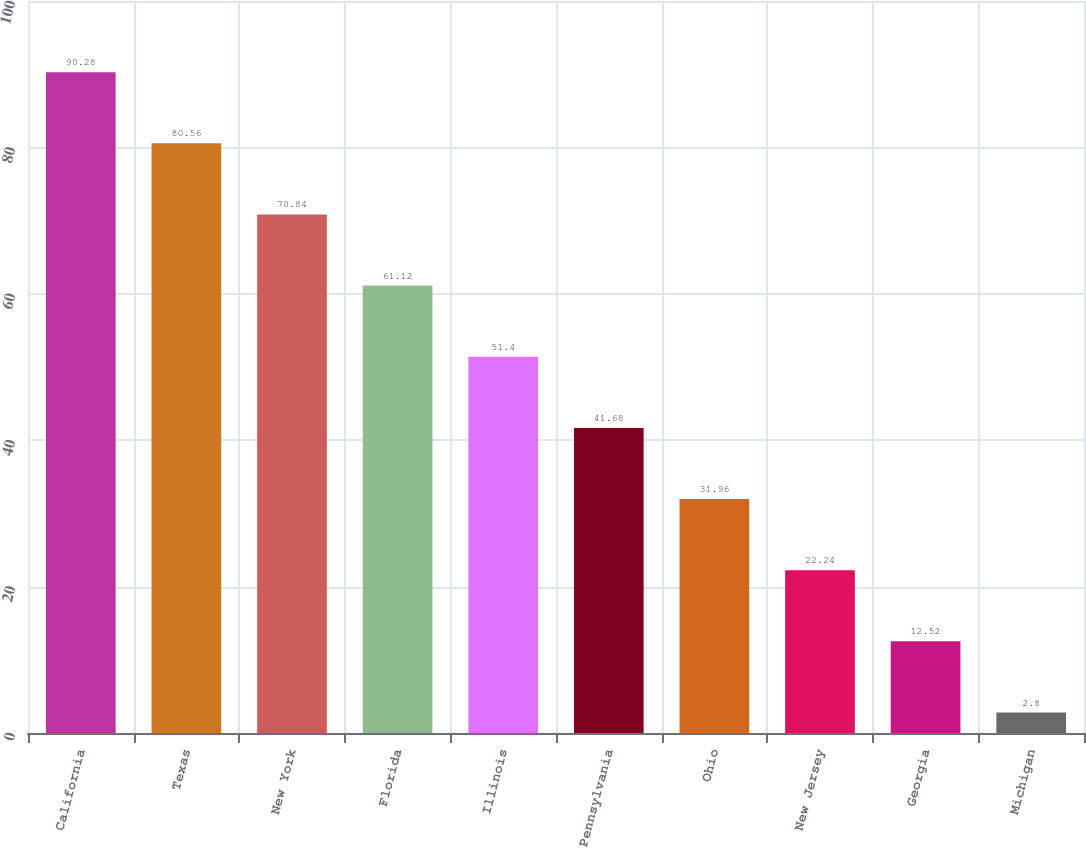Convert chart to OTSL. <chart><loc_0><loc_0><loc_500><loc_500><bar_chart><fcel>California<fcel>Texas<fcel>New York<fcel>Florida<fcel>Illinois<fcel>Pennsylvania<fcel>Ohio<fcel>New Jersey<fcel>Georgia<fcel>Michigan<nl><fcel>90.28<fcel>80.56<fcel>70.84<fcel>61.12<fcel>51.4<fcel>41.68<fcel>31.96<fcel>22.24<fcel>12.52<fcel>2.8<nl></chart> 